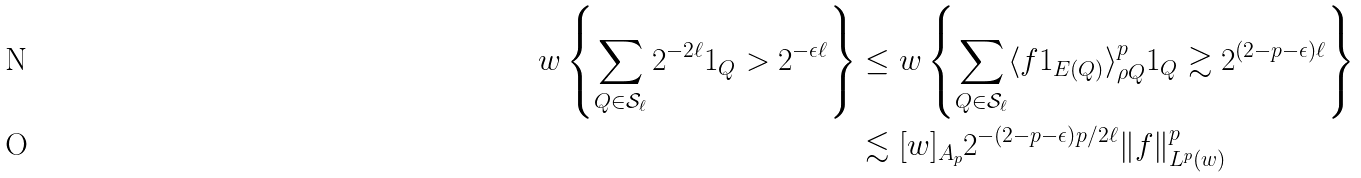Convert formula to latex. <formula><loc_0><loc_0><loc_500><loc_500>w \left \{ \sum _ { Q \in \mathcal { S } _ { \ell } } 2 ^ { - 2 \ell } 1 _ { Q } > 2 ^ { - \epsilon \ell } \right \} & \leq w \left \{ \sum _ { Q \in \mathcal { S } _ { \ell } } \langle f 1 _ { E ( Q ) } \rangle _ { \rho Q } ^ { p } 1 _ { Q } \gtrsim 2 ^ { ( 2 - p - \epsilon ) \ell } \right \} \\ & \lesssim [ w ] _ { A _ { p } } 2 ^ { - ( 2 - p - \epsilon ) p / 2 \ell } \| f \| _ { L ^ { p } ( w ) } ^ { p }</formula> 